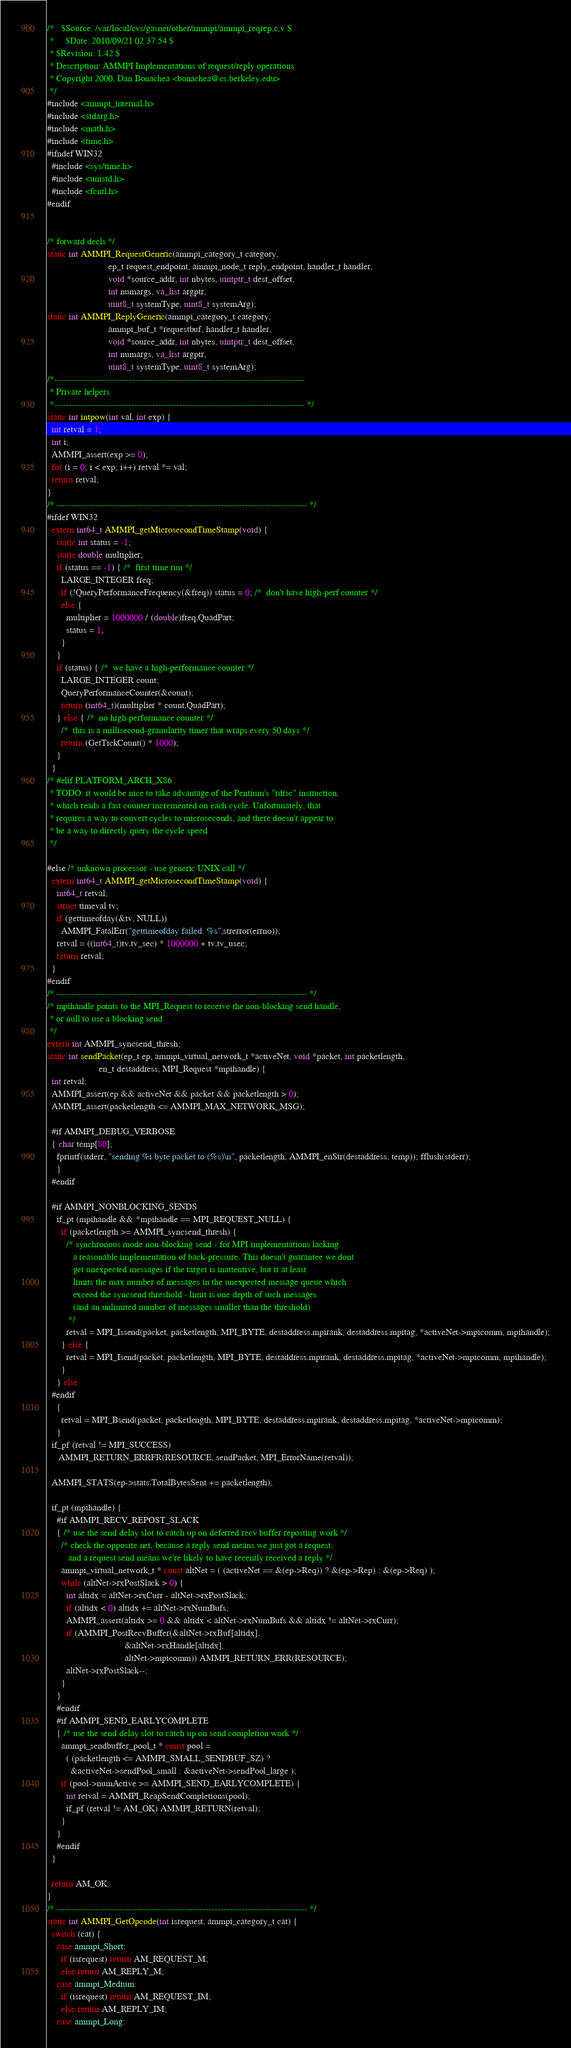Convert code to text. <code><loc_0><loc_0><loc_500><loc_500><_C_>/*   $Source: /var/local/cvs/gasnet/other/ammpi/ammpi_reqrep.c,v $
 *     $Date: 2010/09/21 02:37:54 $
 * $Revision: 1.42 $
 * Description: AMMPI Implementations of request/reply operations
 * Copyright 2000, Dan Bonachea <bonachea@cs.berkeley.edu>
 */
#include <ammpi_internal.h>
#include <stdarg.h>
#include <math.h>
#include <time.h>
#ifndef WIN32
  #include <sys/time.h>
  #include <unistd.h>
  #include <fcntl.h>
#endif


/* forward decls */
static int AMMPI_RequestGeneric(ammpi_category_t category, 
                          ep_t request_endpoint, ammpi_node_t reply_endpoint, handler_t handler, 
                          void *source_addr, int nbytes, uintptr_t dest_offset, 
                          int numargs, va_list argptr,
                          uint8_t systemType, uint8_t systemArg);
static int AMMPI_ReplyGeneric(ammpi_category_t category, 
                          ammpi_buf_t *requestbuf, handler_t handler, 
                          void *source_addr, int nbytes, uintptr_t dest_offset, 
                          int numargs, va_list argptr,
                          uint8_t systemType, uint8_t systemArg);
/*------------------------------------------------------------------------------------
 * Private helpers
 *------------------------------------------------------------------------------------ */
static int intpow(int val, int exp) {
  int retval = 1;
  int i;
  AMMPI_assert(exp >= 0);
  for (i = 0; i < exp; i++) retval *= val;
  return retval;
}
/* ------------------------------------------------------------------------------------ */
#ifdef WIN32
  extern int64_t AMMPI_getMicrosecondTimeStamp(void) {
    static int status = -1;
    static double multiplier;
    if (status == -1) { /*  first time run */
      LARGE_INTEGER freq;
      if (!QueryPerformanceFrequency(&freq)) status = 0; /*  don't have high-perf counter */
      else {
        multiplier = 1000000 / (double)freq.QuadPart;
        status = 1;
      }
    }
    if (status) { /*  we have a high-performance counter */
      LARGE_INTEGER count;
      QueryPerformanceCounter(&count);
      return (int64_t)(multiplier * count.QuadPart);
    } else { /*  no high-performance counter */
      /*  this is a millisecond-granularity timer that wraps every 50 days */
      return (GetTickCount() * 1000);
    }
  }
/* #elif PLATFORM_ARCH_X86
 * TODO: it would be nice to take advantage of the Pentium's "rdtsc" instruction,
 * which reads a fast counter incremented on each cycle. Unfortunately, that
 * requires a way to convert cycles to microseconds, and there doesn't appear to 
 * be a way to directly query the cycle speed
 */

#else /* unknown processor - use generic UNIX call */
  extern int64_t AMMPI_getMicrosecondTimeStamp(void) {
    int64_t retval;
    struct timeval tv;
    if (gettimeofday(&tv, NULL))
      AMMPI_FatalErr("gettimeofday failed: %s",strerror(errno));
    retval = ((int64_t)tv.tv_sec) * 1000000 + tv.tv_usec;
    return retval;
  }
#endif
/* ------------------------------------------------------------------------------------ */
/* mpihandle points to the MPI_Request to receive the non-blocking send handle, 
 * or null to use a blocking send
 */
extern int AMMPI_syncsend_thresh;
static int sendPacket(ep_t ep, ammpi_virtual_network_t *activeNet, void *packet, int packetlength, 
                      en_t destaddress, MPI_Request *mpihandle) {
  int retval;
  AMMPI_assert(ep && activeNet && packet && packetlength > 0);
  AMMPI_assert(packetlength <= AMMPI_MAX_NETWORK_MSG);

  #if AMMPI_DEBUG_VERBOSE
  { char temp[80];
    fprintf(stderr, "sending %i byte packet to (%s)\n", packetlength, AMMPI_enStr(destaddress, temp)); fflush(stderr);
    }
  #endif

  #if AMMPI_NONBLOCKING_SENDS
    if_pt (mpihandle && *mpihandle == MPI_REQUEST_NULL) {
      if (packetlength >= AMMPI_syncsend_thresh) {
        /* synchronous mode non-blocking send - for MPI implementations lacking 
           a reasonable implementation of back-pressure. This doesn't guarantee we dont
           get unexpected messages if the target is inattentive, but it at least 
           limits the max number of messages in the unexpected message queue which
           exceed the syncsend threshold - limit is one depth of such messages
           (and an unlimited number of messages smaller than the threshold)
         */
        retval = MPI_Issend(packet, packetlength, MPI_BYTE, destaddress.mpirank, destaddress.mpitag, *activeNet->mpicomm, mpihandle);
      } else {
        retval = MPI_Isend(packet, packetlength, MPI_BYTE, destaddress.mpirank, destaddress.mpitag, *activeNet->mpicomm, mpihandle);
      }
    } else
  #endif
    {
      retval = MPI_Bsend(packet, packetlength, MPI_BYTE, destaddress.mpirank, destaddress.mpitag, *activeNet->mpicomm);
    }
  if_pf (retval != MPI_SUCCESS) 
     AMMPI_RETURN_ERRFR(RESOURCE, sendPacket, MPI_ErrorName(retval));        

  AMMPI_STATS(ep->stats.TotalBytesSent += packetlength);

  if_pt (mpihandle) { 
    #if AMMPI_RECV_REPOST_SLACK
    { /* use the send delay slot to catch up on deferred recv buffer reposting work */ 
      /* check the opposite net, because a reply send means we just got a request,
         and a request send means we're likely to have recently received a reply */
      ammpi_virtual_network_t * const altNet = ( (activeNet == &(ep->Req)) ? &(ep->Rep) : &(ep->Req) );
      while (altNet->rxPostSlack > 0) {
        int altidx = altNet->rxCurr - altNet->rxPostSlack;
        if (altidx < 0) altidx += altNet->rxNumBufs;
        AMMPI_assert(altidx >= 0 && altidx < altNet->rxNumBufs && altidx != altNet->rxCurr);
        if (AMMPI_PostRecvBuffer(&altNet->rxBuf[altidx],
                                 &altNet->rxHandle[altidx],
                                 altNet->mpicomm)) AMMPI_RETURN_ERR(RESOURCE); 
        altNet->rxPostSlack--;
      }
    }
    #endif
    #if AMMPI_SEND_EARLYCOMPLETE
    { /* use the send delay slot to catch up on send completion work */ 
      ammpi_sendbuffer_pool_t * const pool = 
        ( (packetlength <= AMMPI_SMALL_SENDBUF_SZ) ? 
          &activeNet->sendPool_small : &activeNet->sendPool_large );
      if (pool->numActive >= AMMPI_SEND_EARLYCOMPLETE) {
        int retval = AMMPI_ReapSendCompletions(pool);
        if_pf (retval != AM_OK) AMMPI_RETURN(retval);
      }
    }
    #endif
  }

  return AM_OK;
}
/* ------------------------------------------------------------------------------------ */
static int AMMPI_GetOpcode(int isrequest, ammpi_category_t cat) {
  switch (cat) {
    case ammpi_Short:
      if (isrequest) return AM_REQUEST_M;
      else return AM_REPLY_M;
    case ammpi_Medium:
      if (isrequest) return AM_REQUEST_IM;
      else return AM_REPLY_IM;
    case ammpi_Long:</code> 